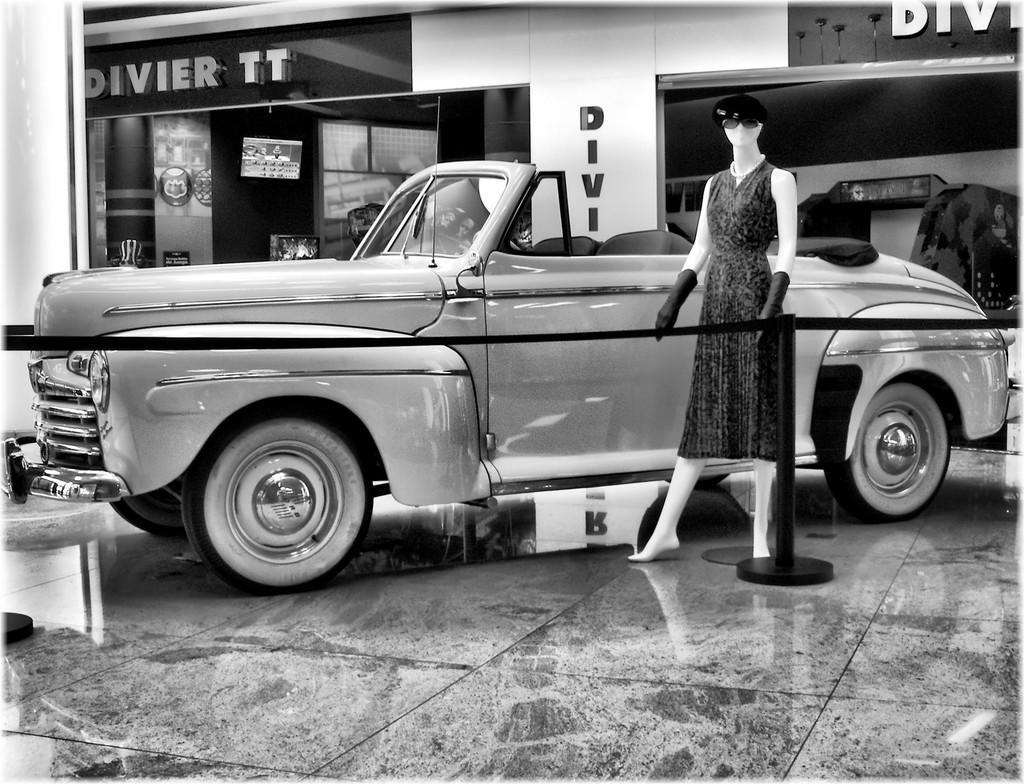Can you describe this image briefly? This is a black and white image where we can see a car and mannequin on the marble ground. In the background, we can see the store. 